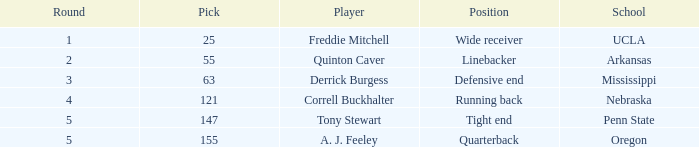What is the sum of rounds where freddie mitchell was picked? 1.0. 